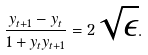<formula> <loc_0><loc_0><loc_500><loc_500>\frac { y _ { t + 1 } - y _ { t } } { 1 + y _ { t } y _ { t + 1 } } = 2 \sqrt { \epsilon } .</formula> 